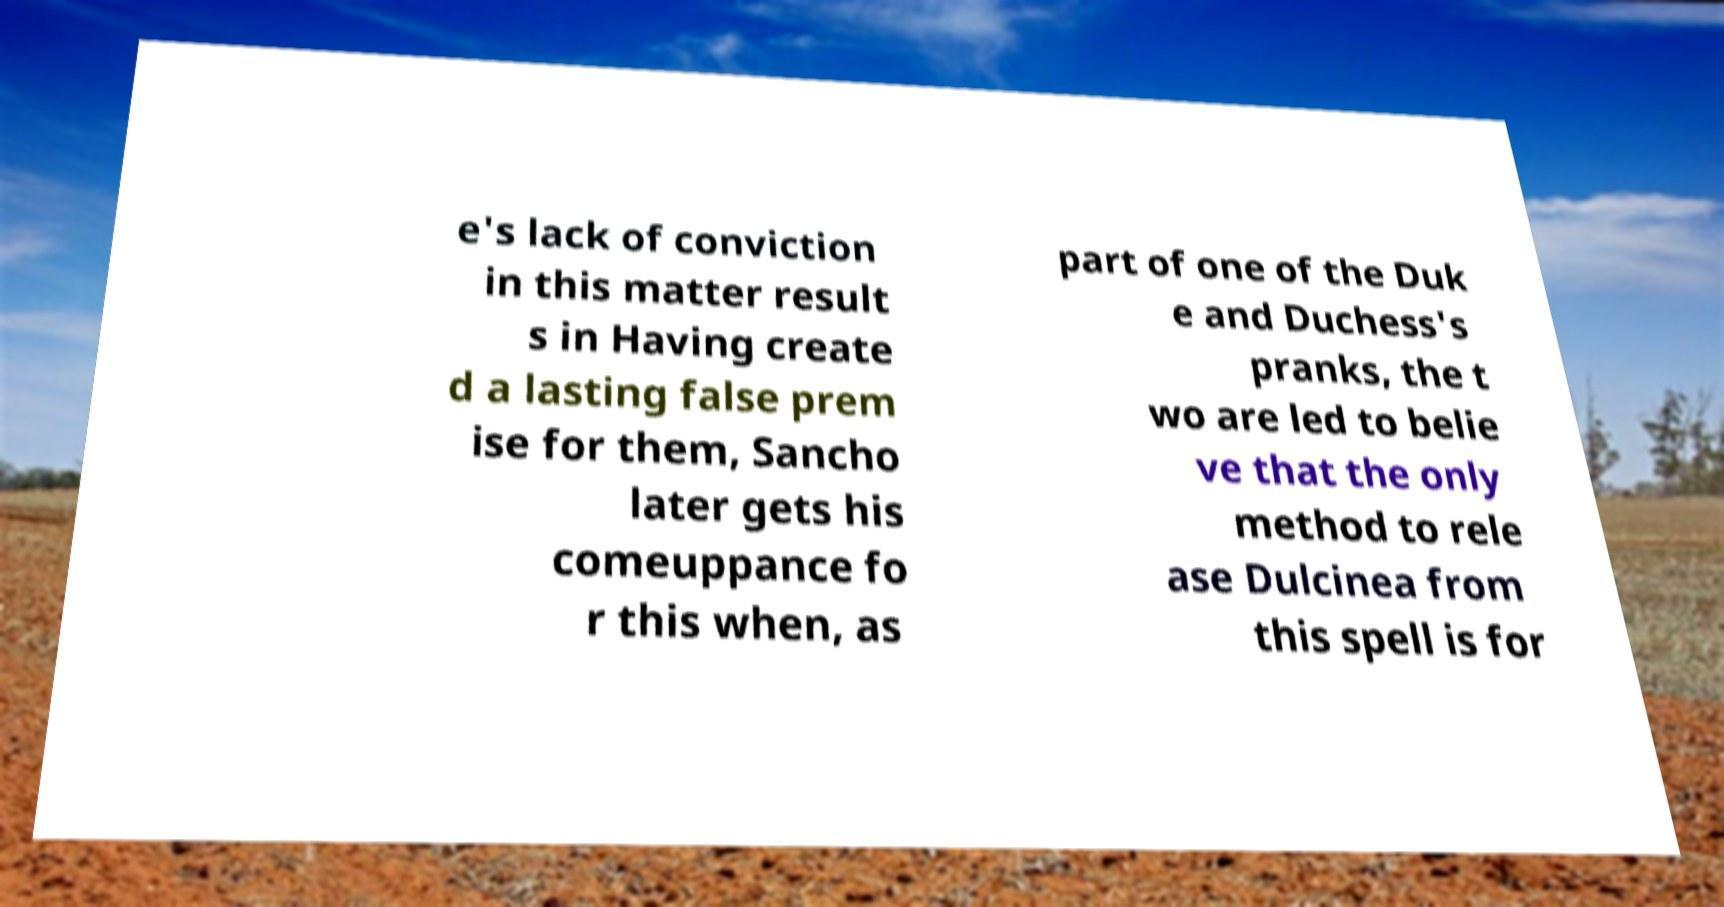Can you accurately transcribe the text from the provided image for me? e's lack of conviction in this matter result s in Having create d a lasting false prem ise for them, Sancho later gets his comeuppance fo r this when, as part of one of the Duk e and Duchess's pranks, the t wo are led to belie ve that the only method to rele ase Dulcinea from this spell is for 